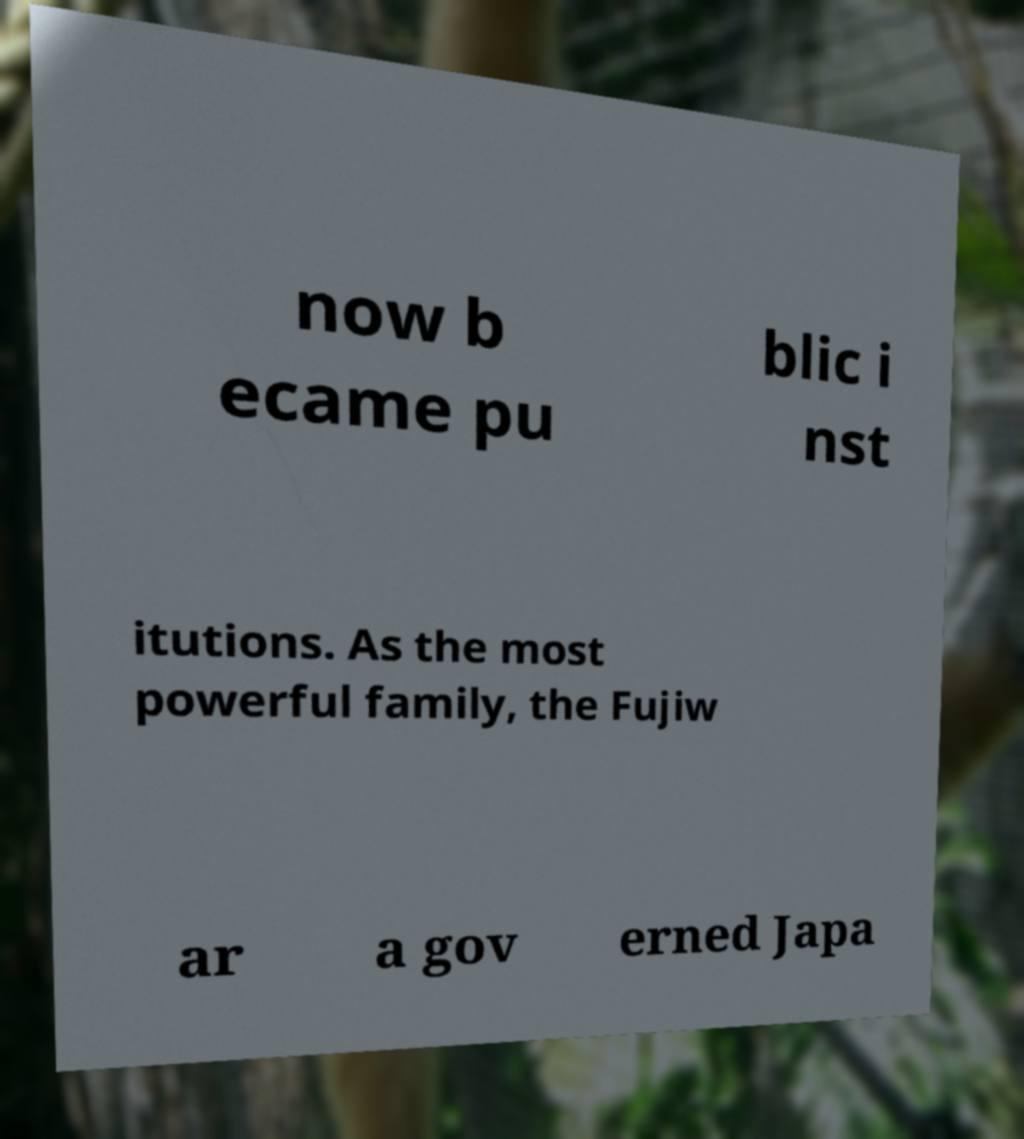Can you accurately transcribe the text from the provided image for me? now b ecame pu blic i nst itutions. As the most powerful family, the Fujiw ar a gov erned Japa 